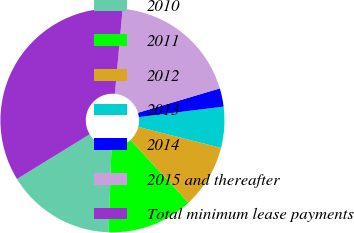Convert chart to OTSL. <chart><loc_0><loc_0><loc_500><loc_500><pie_chart><fcel>2010<fcel>2011<fcel>2012<fcel>2013<fcel>2014<fcel>2015 and thereafter<fcel>Total minimum lease payments<nl><fcel>15.68%<fcel>12.42%<fcel>9.17%<fcel>5.91%<fcel>2.65%<fcel>18.94%<fcel>35.23%<nl></chart> 